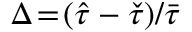<formula> <loc_0><loc_0><loc_500><loc_500>\Delta \, = \, ( \hat { \tau } - \check { \tau } ) / \bar { \tau }</formula> 